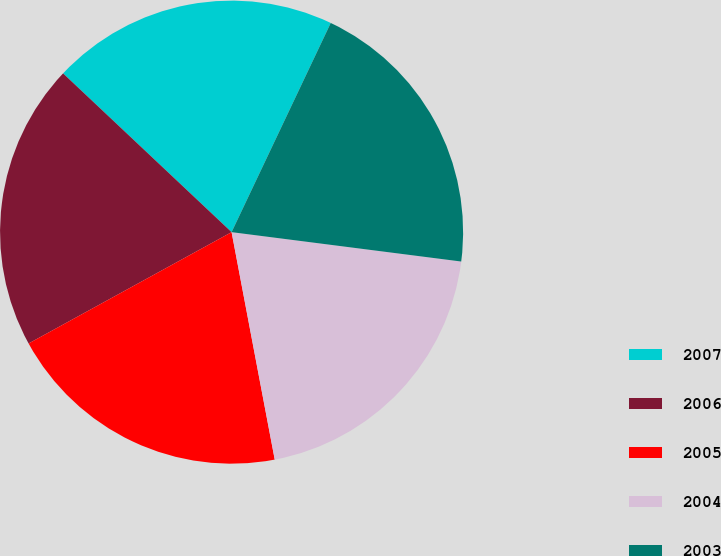Convert chart to OTSL. <chart><loc_0><loc_0><loc_500><loc_500><pie_chart><fcel>2007<fcel>2006<fcel>2005<fcel>2004<fcel>2003<nl><fcel>20.02%<fcel>20.01%<fcel>20.0%<fcel>19.99%<fcel>19.98%<nl></chart> 